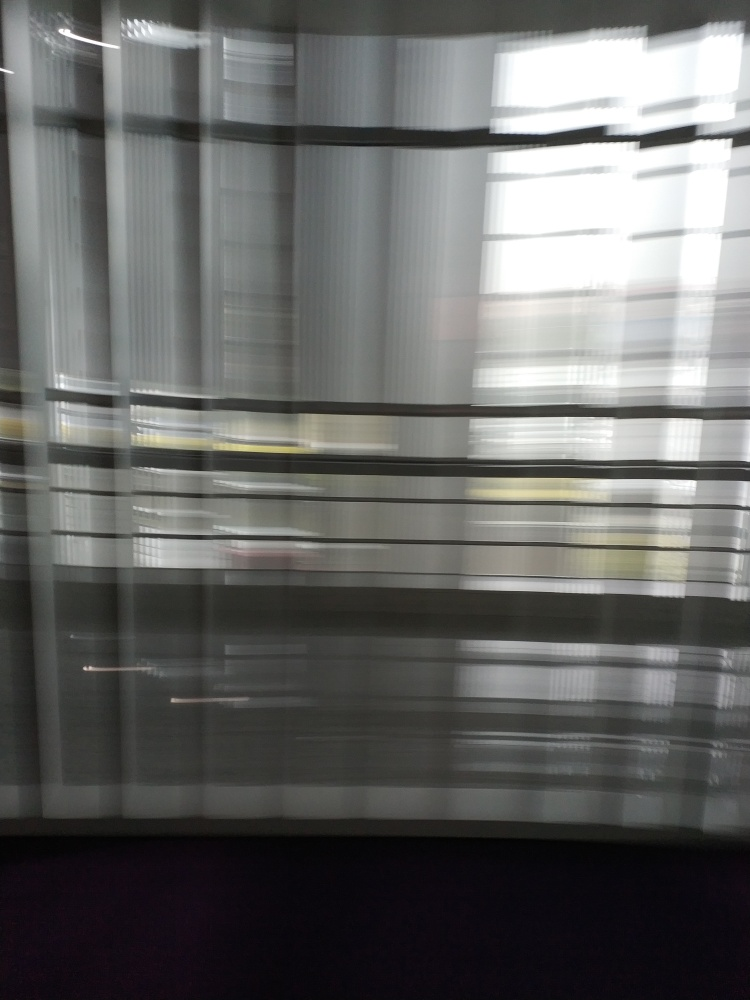Are there any visible artifacts or distortions in the photo? Yes, the photo appears to have motion blur and streaking lines, likely caused by a combination of camera movement and a slower shutter speed during the capture process. This effect gives the image a dynamic and fluid appearance, though it obscures the finer details of the scene behind the blinds. 